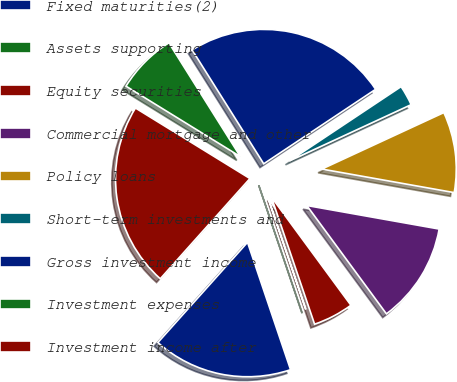Convert chart to OTSL. <chart><loc_0><loc_0><loc_500><loc_500><pie_chart><fcel>Fixed maturities(2)<fcel>Assets supporting<fcel>Equity securities<fcel>Commercial mortgage and other<fcel>Policy loans<fcel>Short-term investments and<fcel>Gross investment income<fcel>Investment expenses<fcel>Investment income after<nl><fcel>16.8%<fcel>0.03%<fcel>4.87%<fcel>12.11%<fcel>9.7%<fcel>2.45%<fcel>24.58%<fcel>7.28%<fcel>22.17%<nl></chart> 